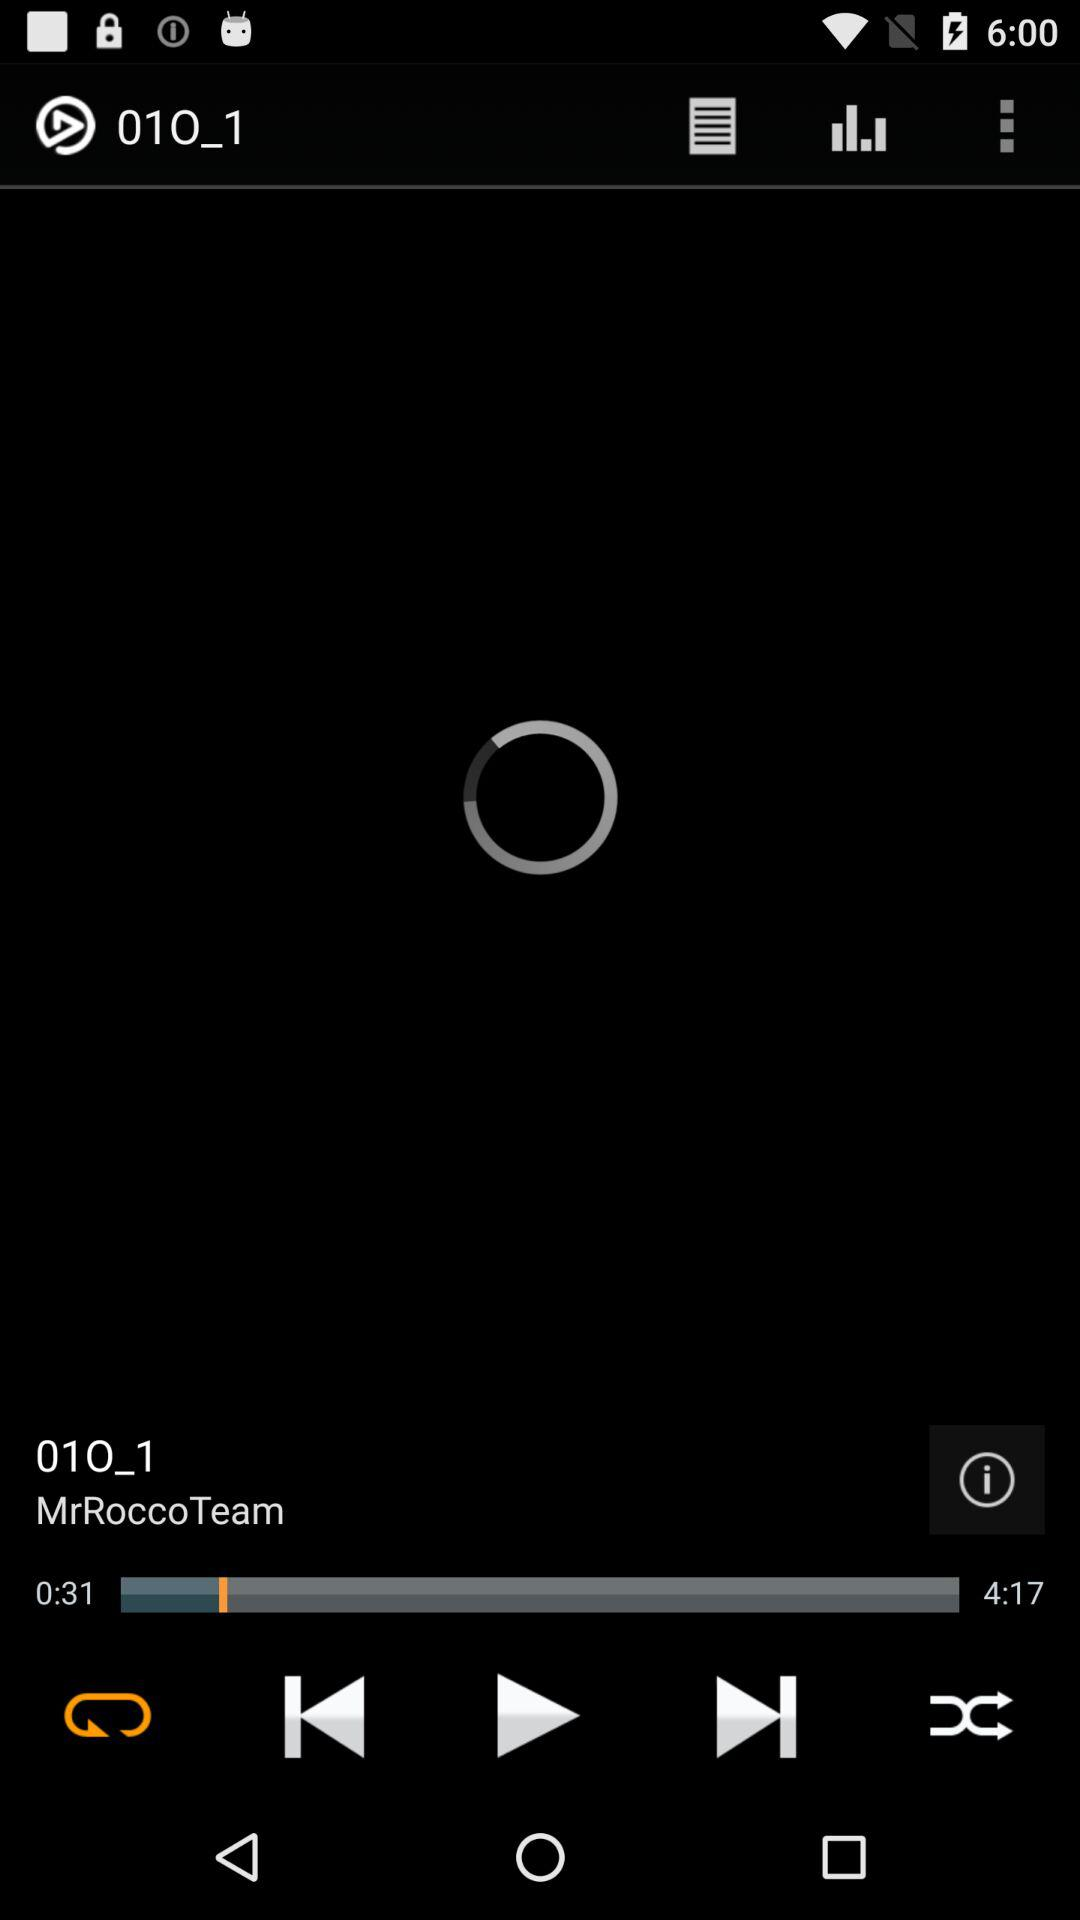What is the name of the audio file? The name of the audio file is "01O_1". 